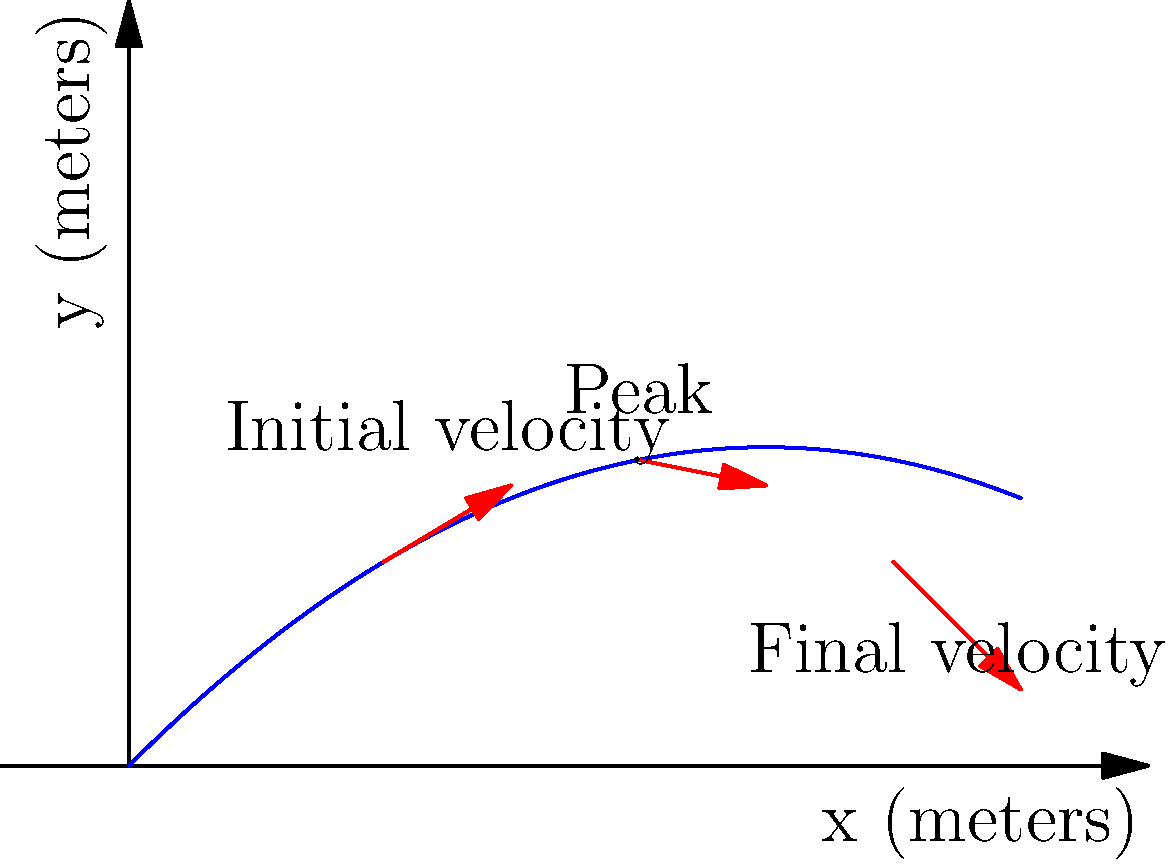As a sports team owner looking to leverage TV coverage, you're analyzing ball trajectories to enhance viewer experience. The graph shows the path of a football during a long pass. If the initial velocity vector is $\vec{v_i} = 20\hat{i} + 15\hat{j}$ m/s, what is the horizontal distance traveled by the ball when it returns to its initial height? To solve this problem, we'll use the properties of projectile motion:

1) The horizontal component of velocity remains constant throughout the motion.
2) The vertical motion is affected by gravity and can be analyzed using kinematic equations.

Let's proceed step-by-step:

1) Time of flight:
   - The ball returns to its initial height, so the total vertical displacement is zero.
   - Using the equation: $y = v_y t - \frac{1}{2}gt^2$
   - $0 = 15t - \frac{1}{2}(9.8)t^2$
   - Solving this quadratic equation: $t = 0$ or $t = \frac{2(15)}{9.8} = 3.06$ seconds

2) Horizontal distance:
   - The horizontal velocity is constant at 20 m/s
   - Distance = velocity × time
   - $d = 20 \times 3.06 = 61.2$ meters

Therefore, the horizontal distance traveled by the football when it returns to its initial height is 61.2 meters.

This analysis can help in positioning cameras and providing insights to viewers, enhancing the TV coverage of your team's games.
Answer: 61.2 meters 